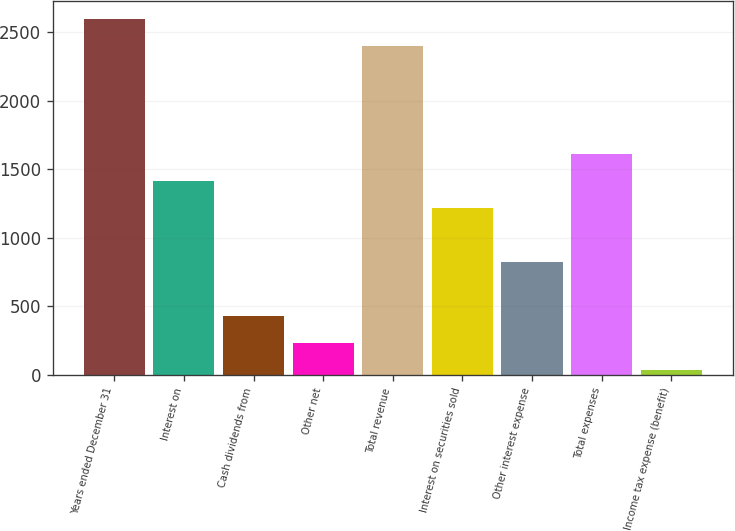Convert chart. <chart><loc_0><loc_0><loc_500><loc_500><bar_chart><fcel>Years ended December 31<fcel>Interest on<fcel>Cash dividends from<fcel>Other net<fcel>Total revenue<fcel>Interest on securities sold<fcel>Other interest expense<fcel>Total expenses<fcel>Income tax expense (benefit)<nl><fcel>2596.6<fcel>1413.4<fcel>427.4<fcel>230.2<fcel>2399.4<fcel>1216.2<fcel>821.8<fcel>1610.6<fcel>33<nl></chart> 